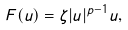Convert formula to latex. <formula><loc_0><loc_0><loc_500><loc_500>F ( u ) = \zeta | u | ^ { p - 1 } u ,</formula> 